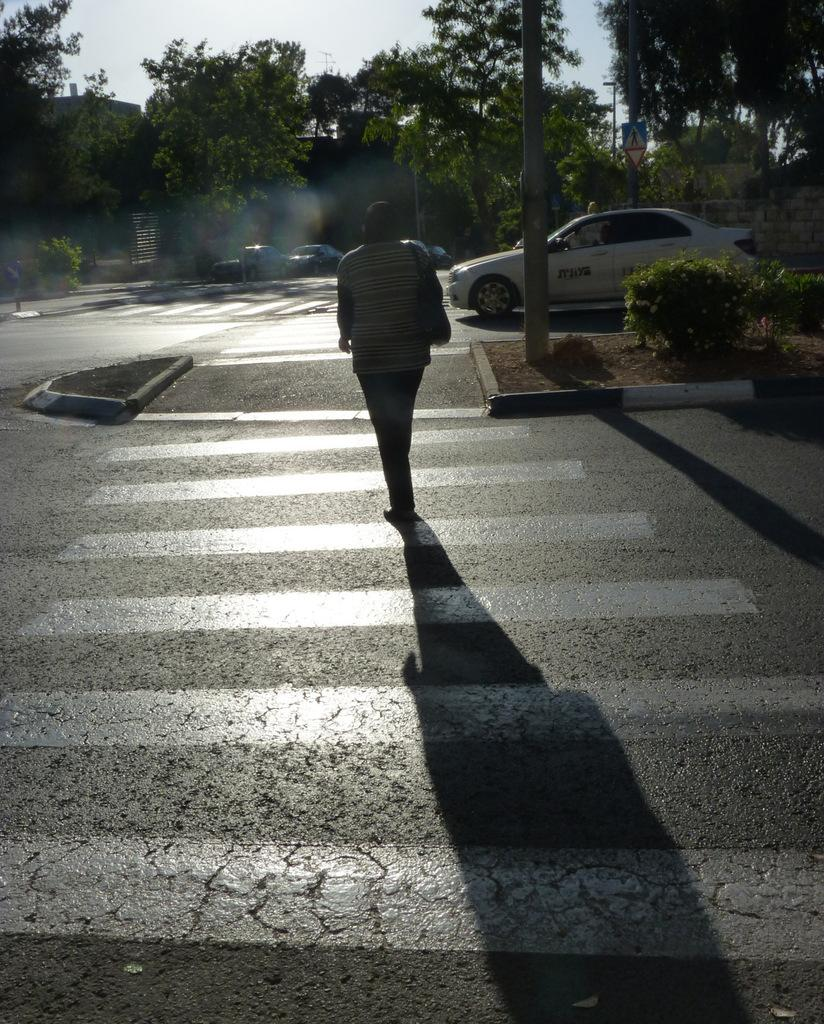What is the person in the image doing? There is a person crossing the road in the image. What else can be seen on the road in the image? There is a car moving on the road. What can be seen in the background of the image? There are trees and houses in the background of the image. What type of industry can be seen in the background of the image? There is no industry visible in the image; it features a person crossing the road, a moving car, and trees and houses in the background. 